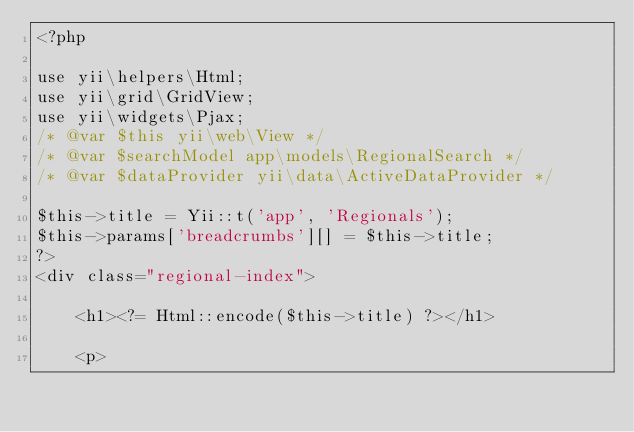<code> <loc_0><loc_0><loc_500><loc_500><_PHP_><?php

use yii\helpers\Html;
use yii\grid\GridView;
use yii\widgets\Pjax;
/* @var $this yii\web\View */
/* @var $searchModel app\models\RegionalSearch */
/* @var $dataProvider yii\data\ActiveDataProvider */

$this->title = Yii::t('app', 'Regionals');
$this->params['breadcrumbs'][] = $this->title;
?>
<div class="regional-index">

    <h1><?= Html::encode($this->title) ?></h1>

    <p></code> 